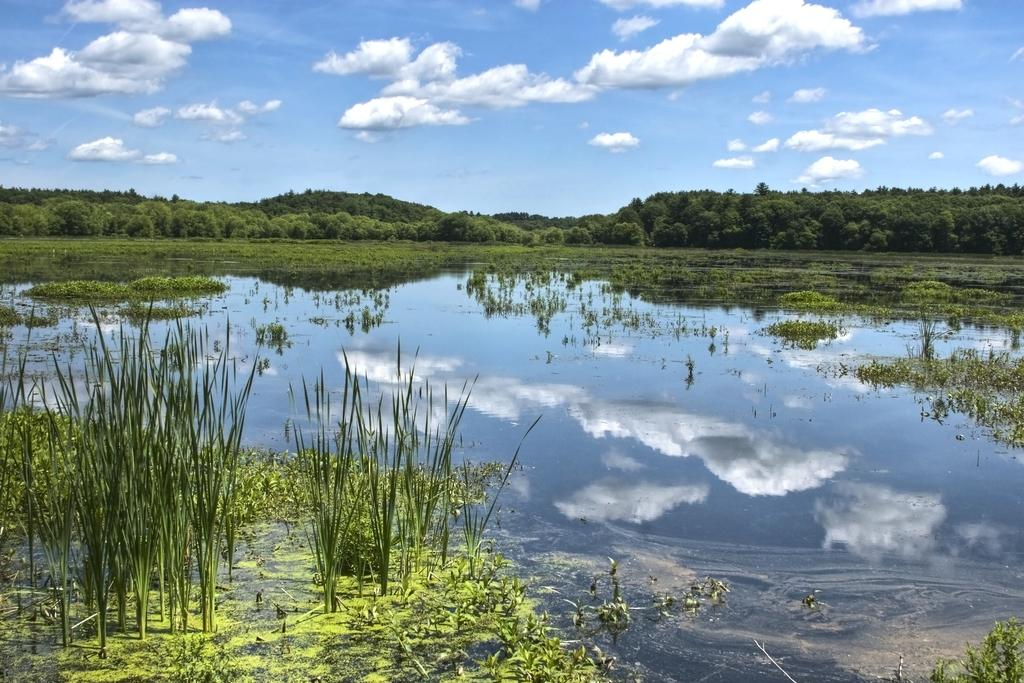What type of vegetation can be seen in the image? There are plants and trees in the image. What type of ground cover is visible in the image? There is grass in the image. What natural element is visible in the image? Water is visible in the image. What is visible in the background of the image? The sky is visible in the background of the image. What can be seen in the sky in the image? Clouds are present in the sky. Who is the manager of the yoke in the image? There is no yoke present in the image, so it is not possible to determine who the manager might be. 